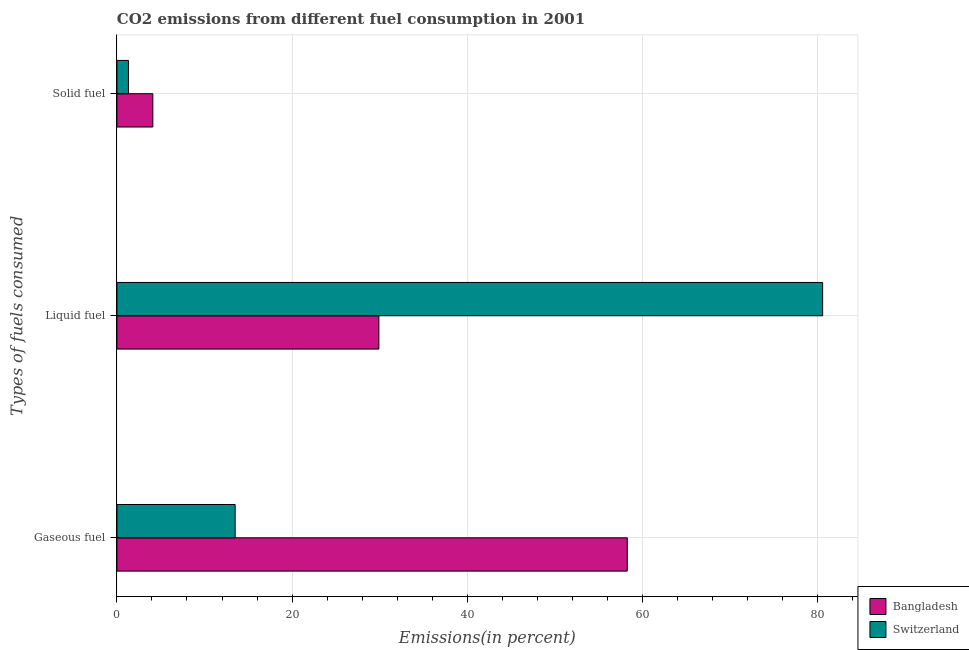How many different coloured bars are there?
Give a very brief answer. 2. Are the number of bars on each tick of the Y-axis equal?
Your answer should be very brief. Yes. What is the label of the 1st group of bars from the top?
Offer a very short reply. Solid fuel. What is the percentage of liquid fuel emission in Switzerland?
Your answer should be compact. 80.6. Across all countries, what is the maximum percentage of liquid fuel emission?
Provide a short and direct response. 80.6. Across all countries, what is the minimum percentage of solid fuel emission?
Offer a terse response. 1.31. In which country was the percentage of solid fuel emission maximum?
Your response must be concise. Bangladesh. In which country was the percentage of solid fuel emission minimum?
Keep it short and to the point. Switzerland. What is the total percentage of gaseous fuel emission in the graph?
Offer a terse response. 71.79. What is the difference between the percentage of liquid fuel emission in Switzerland and that in Bangladesh?
Your answer should be very brief. 50.68. What is the difference between the percentage of liquid fuel emission in Switzerland and the percentage of solid fuel emission in Bangladesh?
Your answer should be compact. 76.5. What is the average percentage of solid fuel emission per country?
Your response must be concise. 2.71. What is the difference between the percentage of liquid fuel emission and percentage of solid fuel emission in Switzerland?
Provide a succinct answer. 79.28. In how many countries, is the percentage of gaseous fuel emission greater than 8 %?
Your answer should be very brief. 2. What is the ratio of the percentage of gaseous fuel emission in Switzerland to that in Bangladesh?
Give a very brief answer. 0.23. Is the percentage of liquid fuel emission in Switzerland less than that in Bangladesh?
Make the answer very short. No. Is the difference between the percentage of liquid fuel emission in Switzerland and Bangladesh greater than the difference between the percentage of solid fuel emission in Switzerland and Bangladesh?
Provide a short and direct response. Yes. What is the difference between the highest and the second highest percentage of gaseous fuel emission?
Keep it short and to the point. 44.78. What is the difference between the highest and the lowest percentage of gaseous fuel emission?
Your answer should be very brief. 44.78. Is the sum of the percentage of liquid fuel emission in Switzerland and Bangladesh greater than the maximum percentage of solid fuel emission across all countries?
Offer a very short reply. Yes. What does the 2nd bar from the bottom in Liquid fuel represents?
Your answer should be very brief. Switzerland. Is it the case that in every country, the sum of the percentage of gaseous fuel emission and percentage of liquid fuel emission is greater than the percentage of solid fuel emission?
Provide a succinct answer. Yes. How many countries are there in the graph?
Give a very brief answer. 2. Does the graph contain any zero values?
Your answer should be very brief. No. Where does the legend appear in the graph?
Your answer should be very brief. Bottom right. How many legend labels are there?
Offer a terse response. 2. How are the legend labels stacked?
Your answer should be very brief. Vertical. What is the title of the graph?
Keep it short and to the point. CO2 emissions from different fuel consumption in 2001. What is the label or title of the X-axis?
Give a very brief answer. Emissions(in percent). What is the label or title of the Y-axis?
Offer a terse response. Types of fuels consumed. What is the Emissions(in percent) of Bangladesh in Gaseous fuel?
Make the answer very short. 58.29. What is the Emissions(in percent) in Switzerland in Gaseous fuel?
Your answer should be compact. 13.5. What is the Emissions(in percent) of Bangladesh in Liquid fuel?
Offer a terse response. 29.92. What is the Emissions(in percent) of Switzerland in Liquid fuel?
Your answer should be very brief. 80.6. What is the Emissions(in percent) of Bangladesh in Solid fuel?
Make the answer very short. 4.1. What is the Emissions(in percent) in Switzerland in Solid fuel?
Your answer should be very brief. 1.31. Across all Types of fuels consumed, what is the maximum Emissions(in percent) in Bangladesh?
Your answer should be very brief. 58.29. Across all Types of fuels consumed, what is the maximum Emissions(in percent) of Switzerland?
Provide a succinct answer. 80.6. Across all Types of fuels consumed, what is the minimum Emissions(in percent) of Bangladesh?
Your response must be concise. 4.1. Across all Types of fuels consumed, what is the minimum Emissions(in percent) in Switzerland?
Give a very brief answer. 1.31. What is the total Emissions(in percent) of Bangladesh in the graph?
Make the answer very short. 92.31. What is the total Emissions(in percent) in Switzerland in the graph?
Your response must be concise. 95.42. What is the difference between the Emissions(in percent) in Bangladesh in Gaseous fuel and that in Liquid fuel?
Make the answer very short. 28.37. What is the difference between the Emissions(in percent) of Switzerland in Gaseous fuel and that in Liquid fuel?
Make the answer very short. -67.1. What is the difference between the Emissions(in percent) of Bangladesh in Gaseous fuel and that in Solid fuel?
Ensure brevity in your answer.  54.19. What is the difference between the Emissions(in percent) in Switzerland in Gaseous fuel and that in Solid fuel?
Make the answer very short. 12.19. What is the difference between the Emissions(in percent) of Bangladesh in Liquid fuel and that in Solid fuel?
Your answer should be very brief. 25.82. What is the difference between the Emissions(in percent) of Switzerland in Liquid fuel and that in Solid fuel?
Give a very brief answer. 79.28. What is the difference between the Emissions(in percent) in Bangladesh in Gaseous fuel and the Emissions(in percent) in Switzerland in Liquid fuel?
Provide a succinct answer. -22.31. What is the difference between the Emissions(in percent) in Bangladesh in Gaseous fuel and the Emissions(in percent) in Switzerland in Solid fuel?
Keep it short and to the point. 56.97. What is the difference between the Emissions(in percent) in Bangladesh in Liquid fuel and the Emissions(in percent) in Switzerland in Solid fuel?
Your answer should be very brief. 28.6. What is the average Emissions(in percent) of Bangladesh per Types of fuels consumed?
Give a very brief answer. 30.77. What is the average Emissions(in percent) of Switzerland per Types of fuels consumed?
Your response must be concise. 31.81. What is the difference between the Emissions(in percent) of Bangladesh and Emissions(in percent) of Switzerland in Gaseous fuel?
Keep it short and to the point. 44.78. What is the difference between the Emissions(in percent) of Bangladesh and Emissions(in percent) of Switzerland in Liquid fuel?
Provide a succinct answer. -50.68. What is the difference between the Emissions(in percent) in Bangladesh and Emissions(in percent) in Switzerland in Solid fuel?
Offer a terse response. 2.79. What is the ratio of the Emissions(in percent) of Bangladesh in Gaseous fuel to that in Liquid fuel?
Your answer should be very brief. 1.95. What is the ratio of the Emissions(in percent) of Switzerland in Gaseous fuel to that in Liquid fuel?
Keep it short and to the point. 0.17. What is the ratio of the Emissions(in percent) in Bangladesh in Gaseous fuel to that in Solid fuel?
Make the answer very short. 14.21. What is the ratio of the Emissions(in percent) in Switzerland in Gaseous fuel to that in Solid fuel?
Your response must be concise. 10.27. What is the ratio of the Emissions(in percent) in Bangladesh in Liquid fuel to that in Solid fuel?
Ensure brevity in your answer.  7.29. What is the ratio of the Emissions(in percent) of Switzerland in Liquid fuel to that in Solid fuel?
Keep it short and to the point. 61.32. What is the difference between the highest and the second highest Emissions(in percent) in Bangladesh?
Ensure brevity in your answer.  28.37. What is the difference between the highest and the second highest Emissions(in percent) in Switzerland?
Offer a terse response. 67.1. What is the difference between the highest and the lowest Emissions(in percent) of Bangladesh?
Your response must be concise. 54.19. What is the difference between the highest and the lowest Emissions(in percent) in Switzerland?
Make the answer very short. 79.28. 